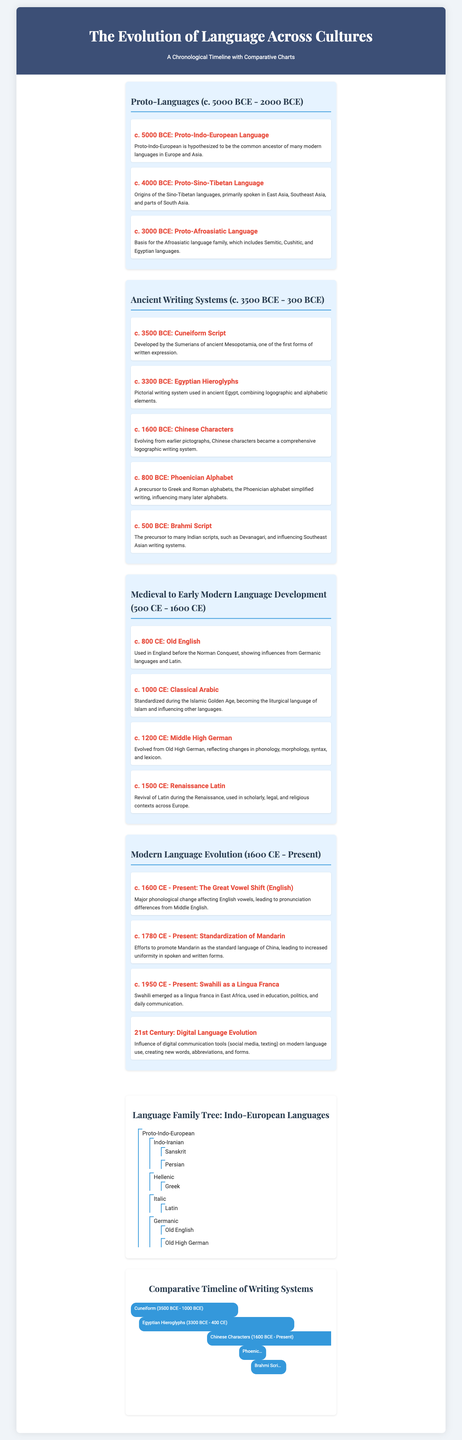What language is hypothesized to be the common ancestor of many modern languages? The document mentions Proto-Indo-European as the common ancestor of many modern languages in Europe and Asia.
Answer: Proto-Indo-European What writing system was developed by the Sumerians? The timeline states that cuneiform script was developed by the Sumerians of ancient Mesopotamia.
Answer: Cuneiform Script In what year range did the Great Vowel Shift occur? The document indicates that the Great Vowel Shift began around 1600 CE and continues to the present.
Answer: 1600 CE - Present Which ancient writing system includes logographic and alphabetic elements? Egyptian hieroglyphs are highlighted as a system that combines logographic and alphabetic elements.
Answer: Egyptian Hieroglyphs What is the earliest identified Proto-language in the timeline? The timeline pinpoints Proto-Indo-European as the earliest described Proto-language around 5000 BCE.
Answer: Proto-Indo-European Which language family does Old English belong to? Old English is categorized under the Germanic languages in the timeline section on medieval language development.
Answer: Germanic How long did Chinese characters evolve according to the document? The timeline states that Chinese characters evolved from 1600 BCE to the present.
Answer: 1600 BCE - Present What major change affected English vowels? The document refers to the Great Vowel Shift as a significant phonological change in English.
Answer: Great Vowel Shift What language emerged as a lingua franca in East Africa? The timeline indicates that Swahili emerged as a lingua franca in East Africa during the latter half of the 20th century.
Answer: Swahili 